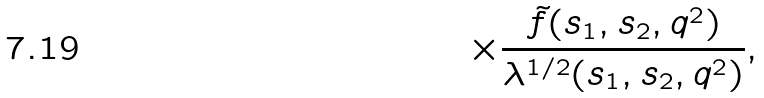<formula> <loc_0><loc_0><loc_500><loc_500>\times \frac { \tilde { f } ( s _ { 1 } , s _ { 2 } , q ^ { 2 } ) } { \lambda ^ { 1 / 2 } ( s _ { 1 } , s _ { 2 } , q ^ { 2 } ) } ,</formula> 